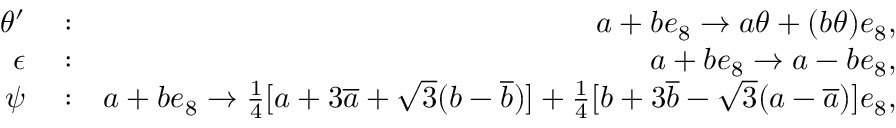Convert formula to latex. <formula><loc_0><loc_0><loc_500><loc_500>\begin{array} { r l r } { \theta ^ { \prime } } & \colon } & { a + b e _ { 8 } \rightarrow a \theta + ( b \theta ) e _ { 8 } , } \\ { \epsilon } & \colon } & { a + b e _ { 8 } \rightarrow a - b e _ { 8 } , } \\ { \psi } & \colon } & { a + b e _ { 8 } \rightarrow \frac { 1 } { 4 } [ a + 3 \overline { a } + \sqrt { 3 } ( b - \overline { b } ) ] + \frac { 1 } { 4 } [ b + 3 \overline { b } - \sqrt { 3 } ( a - \overline { a } ) ] e _ { 8 } , } \end{array}</formula> 